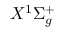Convert formula to latex. <formula><loc_0><loc_0><loc_500><loc_500>X ^ { 1 } \Sigma _ { g } ^ { + }</formula> 